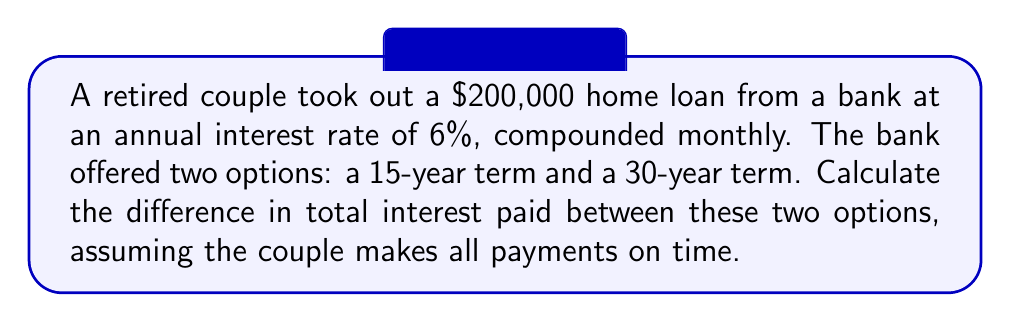Can you answer this question? To solve this problem, we need to calculate the monthly payments and total interest paid for both loan terms. We'll use the amortization formula and then compare the results.

1. Monthly payment calculation:
   The formula for monthly payment is:
   $$P = L \frac{r(1+r)^n}{(1+r)^n - 1}$$
   Where:
   $P$ = monthly payment
   $L$ = loan amount
   $r$ = monthly interest rate (annual rate / 12)
   $n$ = total number of monthly payments

2. For the 15-year loan:
   $L = 200,000$
   $r = 0.06 / 12 = 0.005$
   $n = 15 * 12 = 180$

   $$P_{15} = 200,000 \frac{0.005(1+0.005)^{180}}{(1+0.005)^{180} - 1} \approx 1,687.71$$

3. For the 30-year loan:
   $L = 200,000$
   $r = 0.06 / 12 = 0.005$
   $n = 30 * 12 = 360$

   $$P_{30} = 200,000 \frac{0.005(1+0.005)^{360}}{(1+0.005)^{360} - 1} \approx 1,199.10$$

4. Total amount paid:
   15-year loan: $1,687.71 * 180 = 303,787.80$
   30-year loan: $1,199.10 * 360 = 431,676.00$

5. Total interest paid:
   15-year loan: $303,787.80 - 200,000 = 103,787.80$
   30-year loan: $431,676.00 - 200,000 = 231,676.00$

6. Difference in total interest paid:
   $231,676.00 - 103,787.80 = 127,888.20$

Therefore, the couple would pay $127,888.20 more in interest with the 30-year loan compared to the 15-year loan.
Answer: $127,888.20 